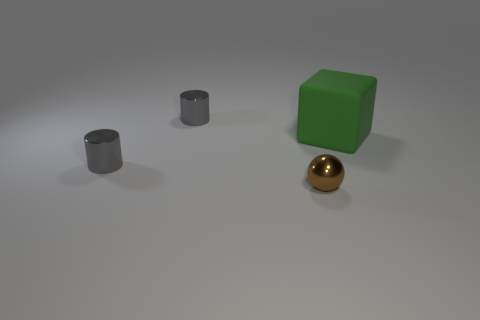Add 2 shiny blocks. How many objects exist? 6 Subtract 1 spheres. How many spheres are left? 0 Subtract all large green rubber blocks. Subtract all small gray metal objects. How many objects are left? 1 Add 4 cubes. How many cubes are left? 5 Add 2 small blocks. How many small blocks exist? 2 Subtract 0 green balls. How many objects are left? 4 Subtract all blocks. How many objects are left? 3 Subtract all purple cylinders. Subtract all brown blocks. How many cylinders are left? 2 Subtract all gray blocks. How many gray balls are left? 0 